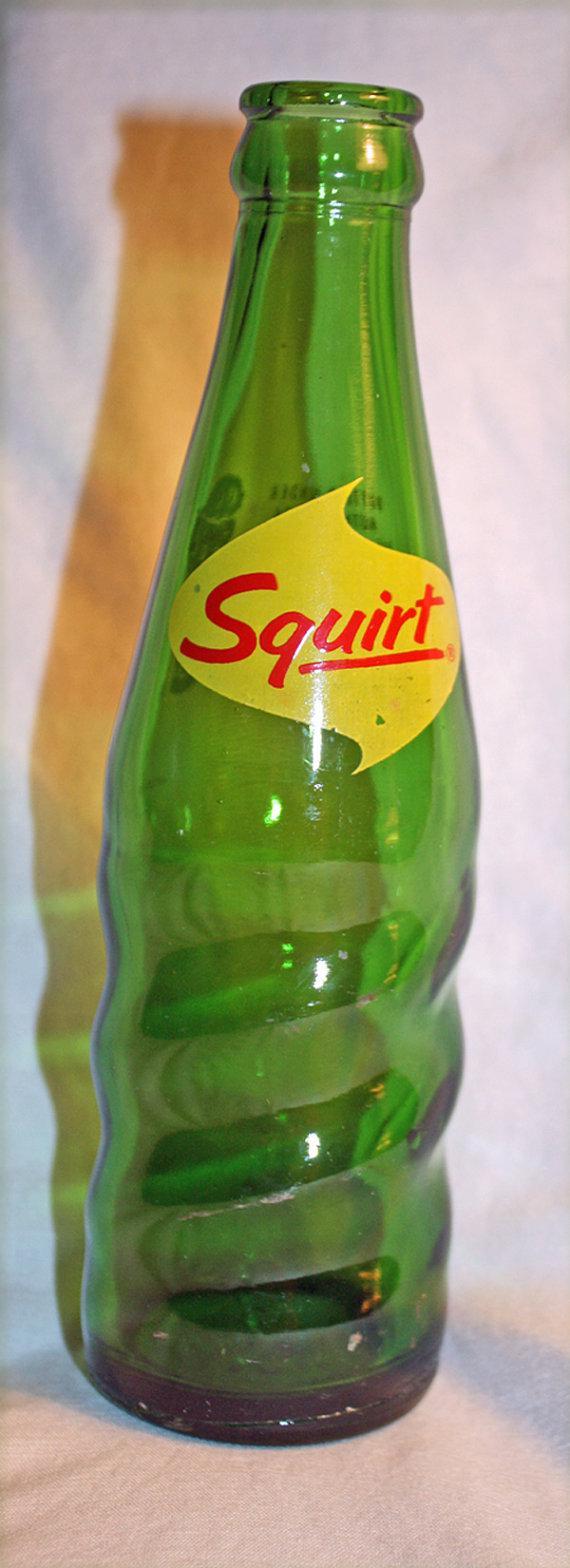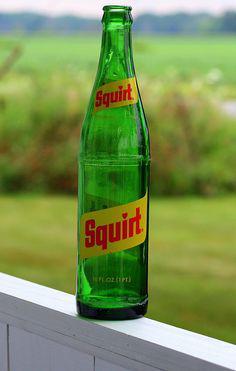The first image is the image on the left, the second image is the image on the right. Assess this claim about the two images: "Each image contains one green bottle, and at least one of the bottles pictured has diagonal ribs around its lower half.". Correct or not? Answer yes or no. Yes. The first image is the image on the left, the second image is the image on the right. Given the left and right images, does the statement "The left image contains exactly four glass bottles." hold true? Answer yes or no. No. 